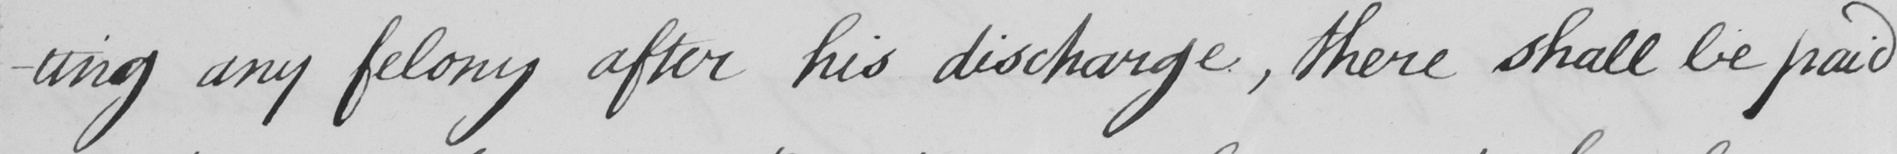Please provide the text content of this handwritten line. -ting any felony after his discharge , there shall be paid 